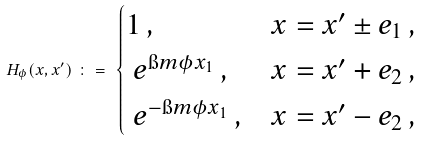<formula> <loc_0><loc_0><loc_500><loc_500>H _ { \phi } ( x , x ^ { \prime } ) \ \colon = \ \begin{cases} 1 \, , & x = x ^ { \prime } \pm e _ { 1 } \, , \\ \ e ^ { \i m \phi x _ { 1 } } \, , & x = x ^ { \prime } + e _ { 2 } \, , \\ \ e ^ { - \i m \phi x _ { 1 } } \, , & x = x ^ { \prime } - e _ { 2 } \, , \end{cases}</formula> 